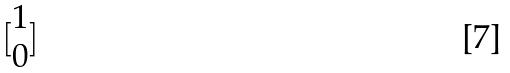<formula> <loc_0><loc_0><loc_500><loc_500>[ \begin{matrix} 1 \\ 0 \end{matrix} ]</formula> 